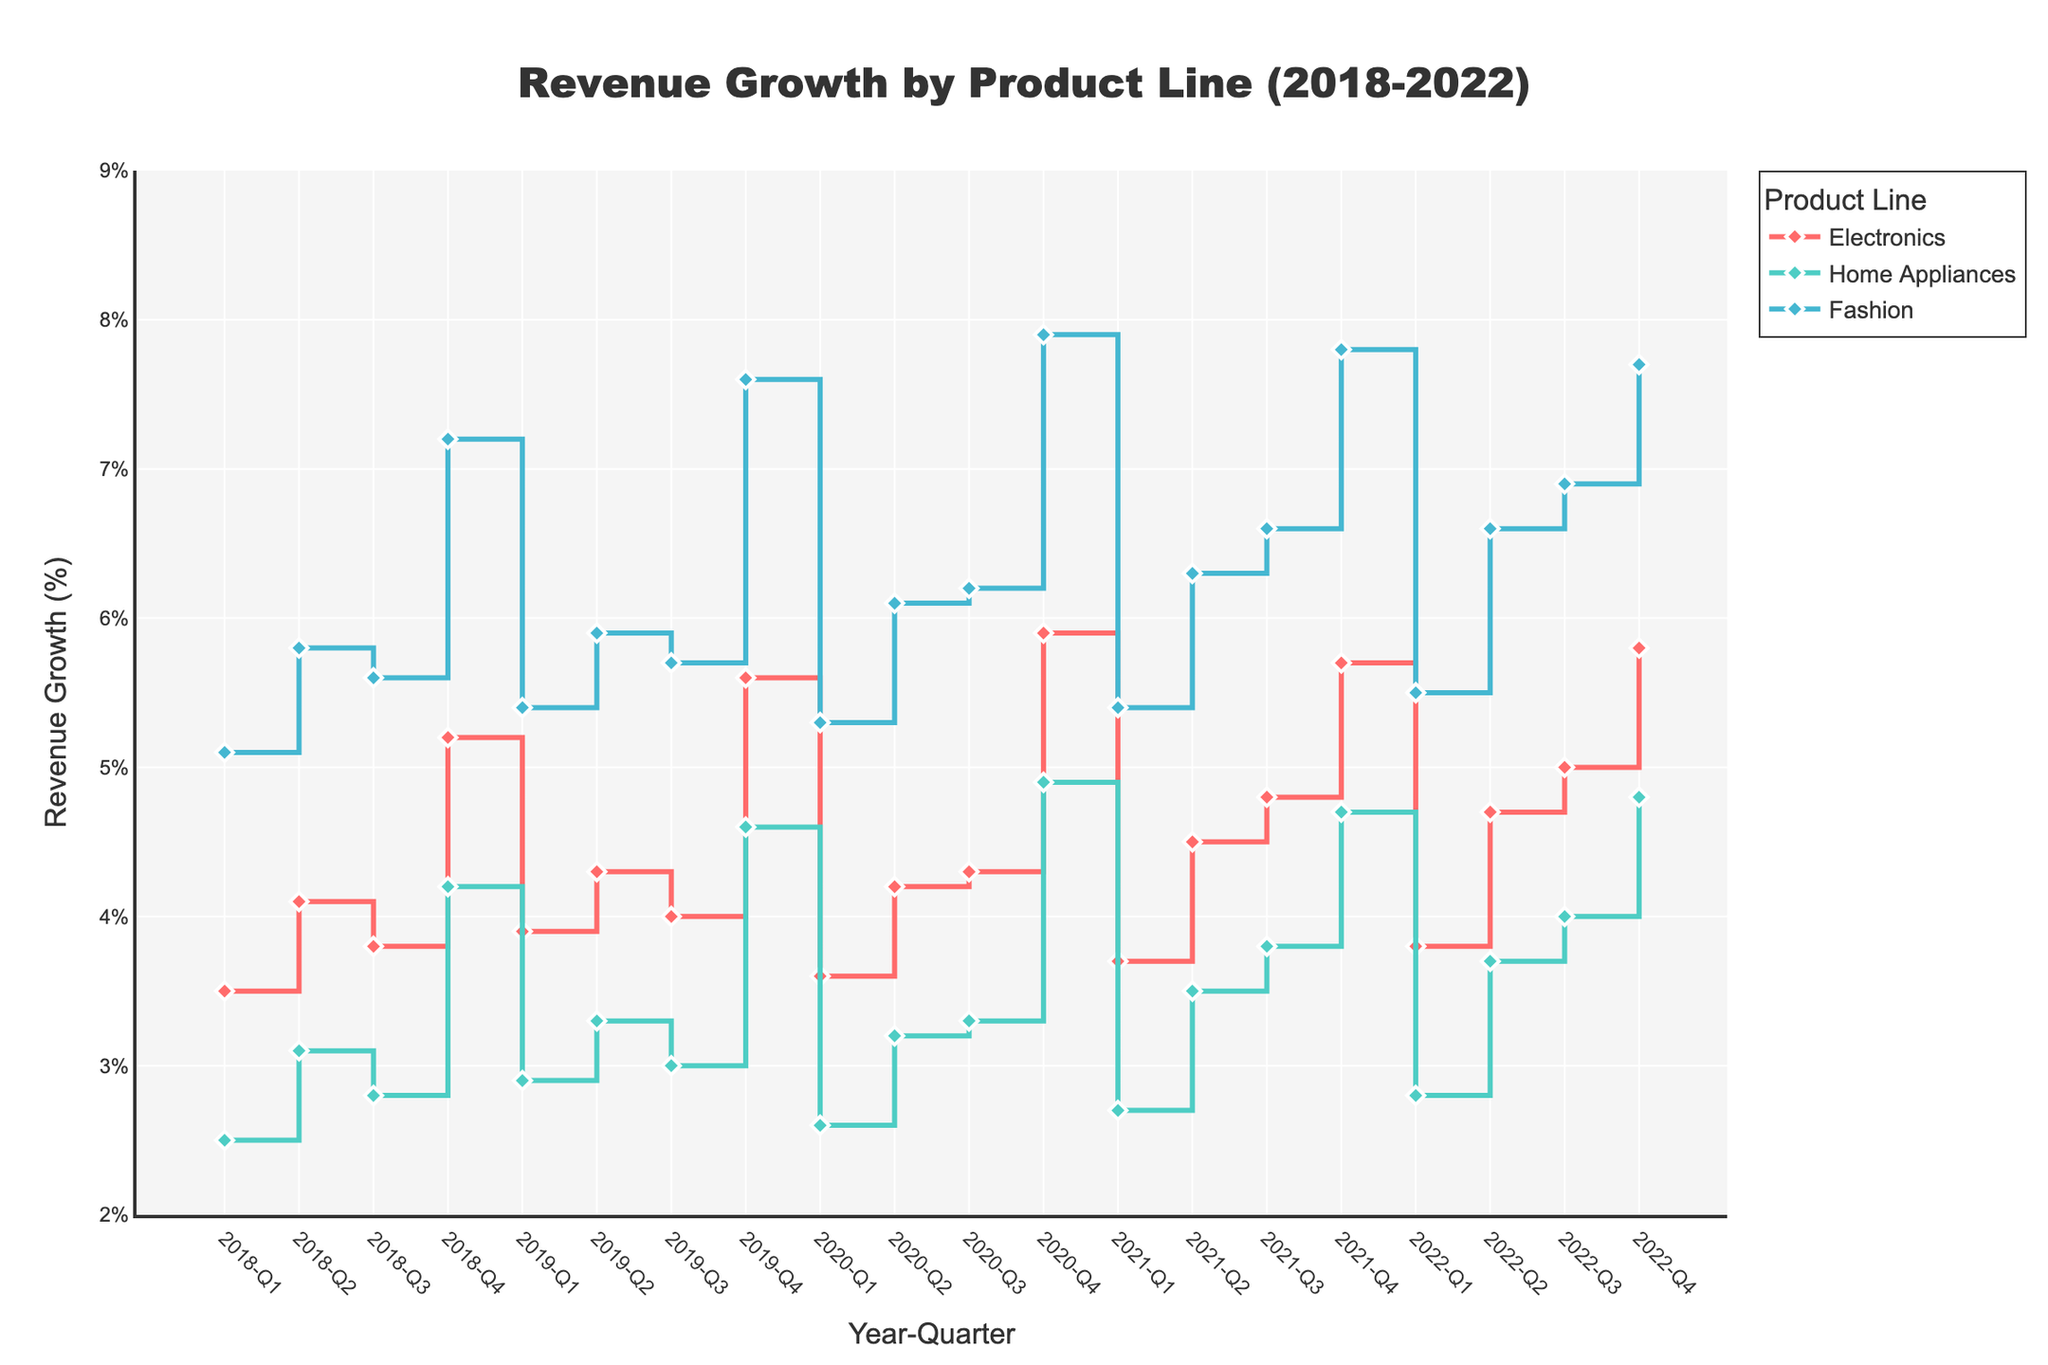What is the revenue growth (%) for Fashion in Q4 of 2020? First, find the Fashion product line in the figure. Then locate the quarter Q4 of 2020. The corresponding figure shows a revenue growth value.
Answer: 7.9 Which product line had the highest revenue growth in Q1 of 2022? Check the revenue growth percentages for all product lines in Q1 of 2022 and compare them. The product line with the highest percentage is the one we are looking for.
Answer: Fashion What is the average revenue growth for Electronics in 2021? Extract the revenue growth values for Electronics in 2021 (3.7, 4.5, 4.8, 5.7). Sum these values and divide by the number of values (4). (3.7 + 4.5 + 4.8 + 5.7) / 4 = 4.675
Answer: 4.675 How did the revenue growth for Home Appliances change from Q3 to Q4 in 2018? Identify the revenue growth for Home Appliances in Q3 (2.8%) and Q4 (4.2%) of 2018. Calculate the difference (4.2% - 2.8%).
Answer: Increased by 1.4% Which product line had the most consistent revenue growth between quarters over the five years? Observe the lines in the figure for each product. The product line whose line has the least fluctuations (smoothest line) is the most consistent.
Answer: Electronics In which quarter and year did Fashion observe its peak revenue growth? Locate the highest point on the Fashion line. The corresponding x-axis value will give the year and quarter.
Answer: Q4, 2020 Compare the revenue growth between Electronics and Home Appliances in Q2 of 2019. Which had higher growth and by how much? Find the revenue growth values for both product lines in Q2 of 2019. Electronics was 4.3% and Home Appliances was 3.3%. Subtract Home Appliances growth from Electronics growth (4.3% - 3.3%).
Answer: Electronics by 1% Calculate the total revenue growth for Fashion over all Q4s from 2018 to 2022. Add the revenue growth values for Fashion in Q4 of each year (7.2%, 7.6%, 7.9%, 7.8%, 7.7%). Sum them up (7.2 + 7.6 + 7.9 + 7.8 + 7.7).
Answer: 38.2 Did Electronics ever surpass 5% revenue growth before 2021? If so, when? Examine the Electronics line before 2021. Highlight the points where it surpassed 5% (look for values beyond 5.0%) and identify the specific quarters.
Answer: Yes, Q4 of 2018 (5.2%) and Q4 of 2019 (5.6%) Which product line showed the greatest increase in revenue growth between two consecutive quarters, and what was that increase? Examine each product line's curve to identify the steepest increase between two points. Calculate the differences and find the maximum. Electronics Q4 2020 to Q1 2021 (5.9% - 3.6%) is 2.3%
Answer: Electronics, 2.3% 